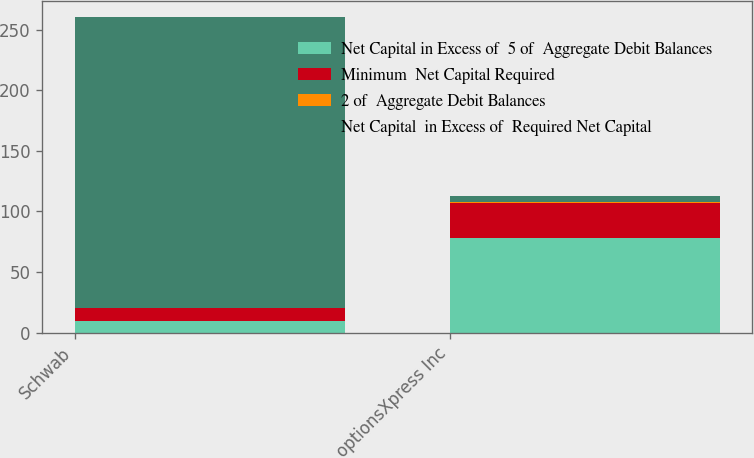Convert chart to OTSL. <chart><loc_0><loc_0><loc_500><loc_500><stacked_bar_chart><ecel><fcel>Schwab<fcel>optionsXpress Inc<nl><fcel>Net Capital in Excess of  5 of  Aggregate Debit Balances<fcel>10<fcel>78<nl><fcel>Minimum  Net Capital Required<fcel>10<fcel>29<nl><fcel>2 of  Aggregate Debit Balances<fcel>0.25<fcel>1<nl><fcel>Net Capital  in Excess of  Required Net Capital<fcel>240<fcel>5<nl></chart> 